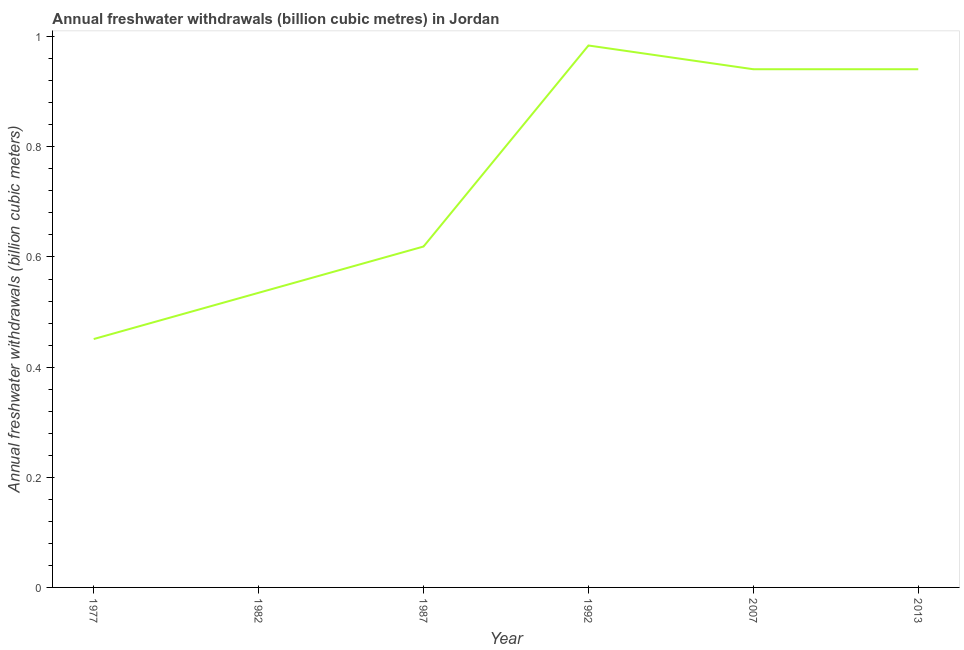What is the annual freshwater withdrawals in 2007?
Provide a short and direct response. 0.94. Across all years, what is the minimum annual freshwater withdrawals?
Offer a terse response. 0.45. In which year was the annual freshwater withdrawals minimum?
Give a very brief answer. 1977. What is the sum of the annual freshwater withdrawals?
Your answer should be very brief. 4.47. What is the difference between the annual freshwater withdrawals in 1987 and 1992?
Your response must be concise. -0.36. What is the average annual freshwater withdrawals per year?
Give a very brief answer. 0.75. What is the median annual freshwater withdrawals?
Keep it short and to the point. 0.78. In how many years, is the annual freshwater withdrawals greater than 0.56 billion cubic meters?
Keep it short and to the point. 4. What is the ratio of the annual freshwater withdrawals in 1982 to that in 2013?
Keep it short and to the point. 0.57. Is the annual freshwater withdrawals in 1977 less than that in 2007?
Offer a very short reply. Yes. Is the difference between the annual freshwater withdrawals in 1977 and 1982 greater than the difference between any two years?
Your response must be concise. No. What is the difference between the highest and the second highest annual freshwater withdrawals?
Offer a very short reply. 0.04. What is the difference between the highest and the lowest annual freshwater withdrawals?
Provide a short and direct response. 0.53. In how many years, is the annual freshwater withdrawals greater than the average annual freshwater withdrawals taken over all years?
Ensure brevity in your answer.  3. How many lines are there?
Your answer should be very brief. 1. What is the difference between two consecutive major ticks on the Y-axis?
Provide a succinct answer. 0.2. What is the title of the graph?
Provide a short and direct response. Annual freshwater withdrawals (billion cubic metres) in Jordan. What is the label or title of the Y-axis?
Provide a short and direct response. Annual freshwater withdrawals (billion cubic meters). What is the Annual freshwater withdrawals (billion cubic meters) in 1977?
Ensure brevity in your answer.  0.45. What is the Annual freshwater withdrawals (billion cubic meters) in 1982?
Your answer should be very brief. 0.54. What is the Annual freshwater withdrawals (billion cubic meters) in 1987?
Your response must be concise. 0.62. What is the Annual freshwater withdrawals (billion cubic meters) of 2007?
Offer a very short reply. 0.94. What is the Annual freshwater withdrawals (billion cubic meters) of 2013?
Ensure brevity in your answer.  0.94. What is the difference between the Annual freshwater withdrawals (billion cubic meters) in 1977 and 1982?
Offer a very short reply. -0.08. What is the difference between the Annual freshwater withdrawals (billion cubic meters) in 1977 and 1987?
Provide a short and direct response. -0.17. What is the difference between the Annual freshwater withdrawals (billion cubic meters) in 1977 and 1992?
Your answer should be compact. -0.53. What is the difference between the Annual freshwater withdrawals (billion cubic meters) in 1977 and 2007?
Provide a succinct answer. -0.49. What is the difference between the Annual freshwater withdrawals (billion cubic meters) in 1977 and 2013?
Provide a succinct answer. -0.49. What is the difference between the Annual freshwater withdrawals (billion cubic meters) in 1982 and 1987?
Offer a very short reply. -0.08. What is the difference between the Annual freshwater withdrawals (billion cubic meters) in 1982 and 1992?
Your answer should be compact. -0.45. What is the difference between the Annual freshwater withdrawals (billion cubic meters) in 1982 and 2007?
Make the answer very short. -0.41. What is the difference between the Annual freshwater withdrawals (billion cubic meters) in 1982 and 2013?
Offer a terse response. -0.41. What is the difference between the Annual freshwater withdrawals (billion cubic meters) in 1987 and 1992?
Your answer should be compact. -0.36. What is the difference between the Annual freshwater withdrawals (billion cubic meters) in 1987 and 2007?
Offer a terse response. -0.32. What is the difference between the Annual freshwater withdrawals (billion cubic meters) in 1987 and 2013?
Provide a succinct answer. -0.32. What is the difference between the Annual freshwater withdrawals (billion cubic meters) in 1992 and 2007?
Your answer should be compact. 0.04. What is the difference between the Annual freshwater withdrawals (billion cubic meters) in 1992 and 2013?
Provide a succinct answer. 0.04. What is the difference between the Annual freshwater withdrawals (billion cubic meters) in 2007 and 2013?
Your response must be concise. 0. What is the ratio of the Annual freshwater withdrawals (billion cubic meters) in 1977 to that in 1982?
Provide a succinct answer. 0.84. What is the ratio of the Annual freshwater withdrawals (billion cubic meters) in 1977 to that in 1987?
Give a very brief answer. 0.73. What is the ratio of the Annual freshwater withdrawals (billion cubic meters) in 1977 to that in 1992?
Make the answer very short. 0.46. What is the ratio of the Annual freshwater withdrawals (billion cubic meters) in 1977 to that in 2007?
Make the answer very short. 0.48. What is the ratio of the Annual freshwater withdrawals (billion cubic meters) in 1977 to that in 2013?
Your answer should be compact. 0.48. What is the ratio of the Annual freshwater withdrawals (billion cubic meters) in 1982 to that in 1987?
Give a very brief answer. 0.86. What is the ratio of the Annual freshwater withdrawals (billion cubic meters) in 1982 to that in 1992?
Provide a succinct answer. 0.54. What is the ratio of the Annual freshwater withdrawals (billion cubic meters) in 1982 to that in 2007?
Make the answer very short. 0.57. What is the ratio of the Annual freshwater withdrawals (billion cubic meters) in 1982 to that in 2013?
Offer a terse response. 0.57. What is the ratio of the Annual freshwater withdrawals (billion cubic meters) in 1987 to that in 1992?
Your answer should be compact. 0.63. What is the ratio of the Annual freshwater withdrawals (billion cubic meters) in 1987 to that in 2007?
Offer a very short reply. 0.66. What is the ratio of the Annual freshwater withdrawals (billion cubic meters) in 1987 to that in 2013?
Give a very brief answer. 0.66. What is the ratio of the Annual freshwater withdrawals (billion cubic meters) in 1992 to that in 2007?
Your response must be concise. 1.05. What is the ratio of the Annual freshwater withdrawals (billion cubic meters) in 1992 to that in 2013?
Give a very brief answer. 1.05. What is the ratio of the Annual freshwater withdrawals (billion cubic meters) in 2007 to that in 2013?
Make the answer very short. 1. 